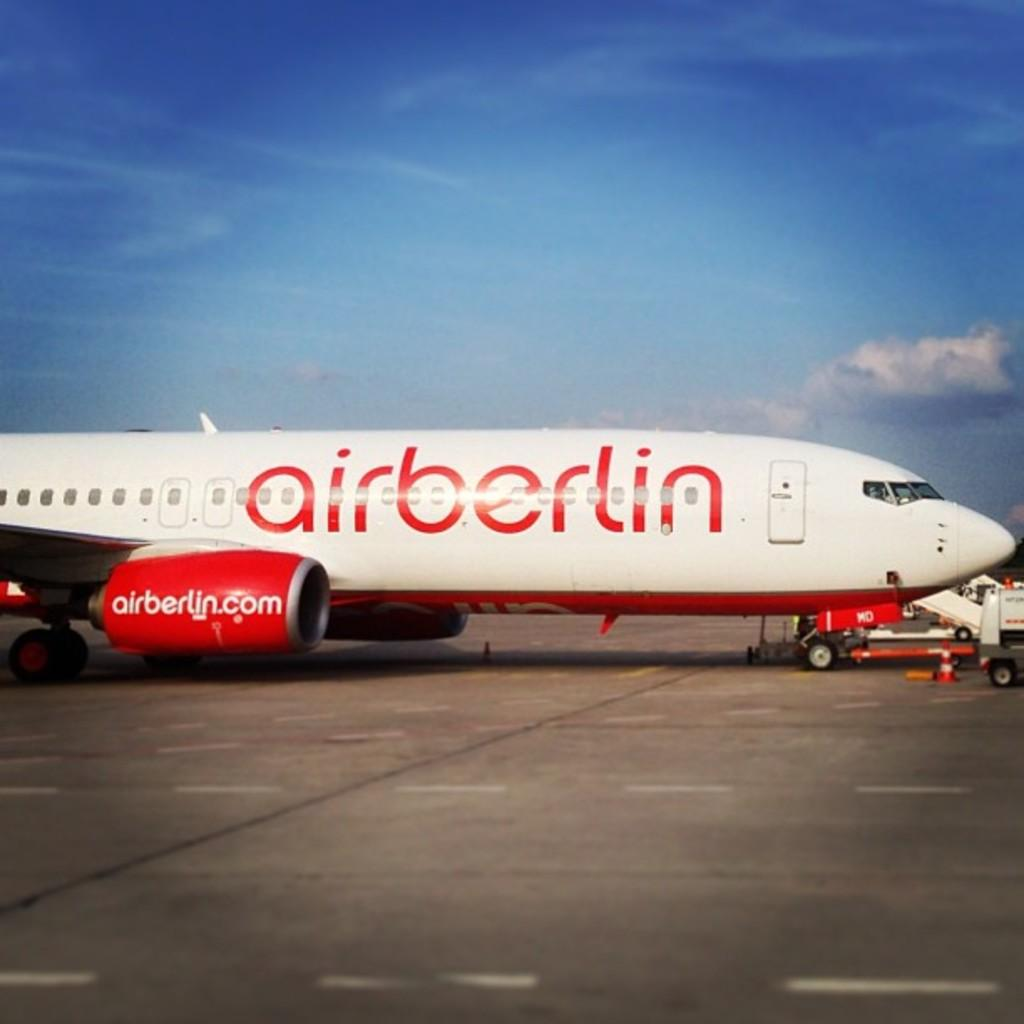<image>
Render a clear and concise summary of the photo. A white and red plane is labeled airberlin. 